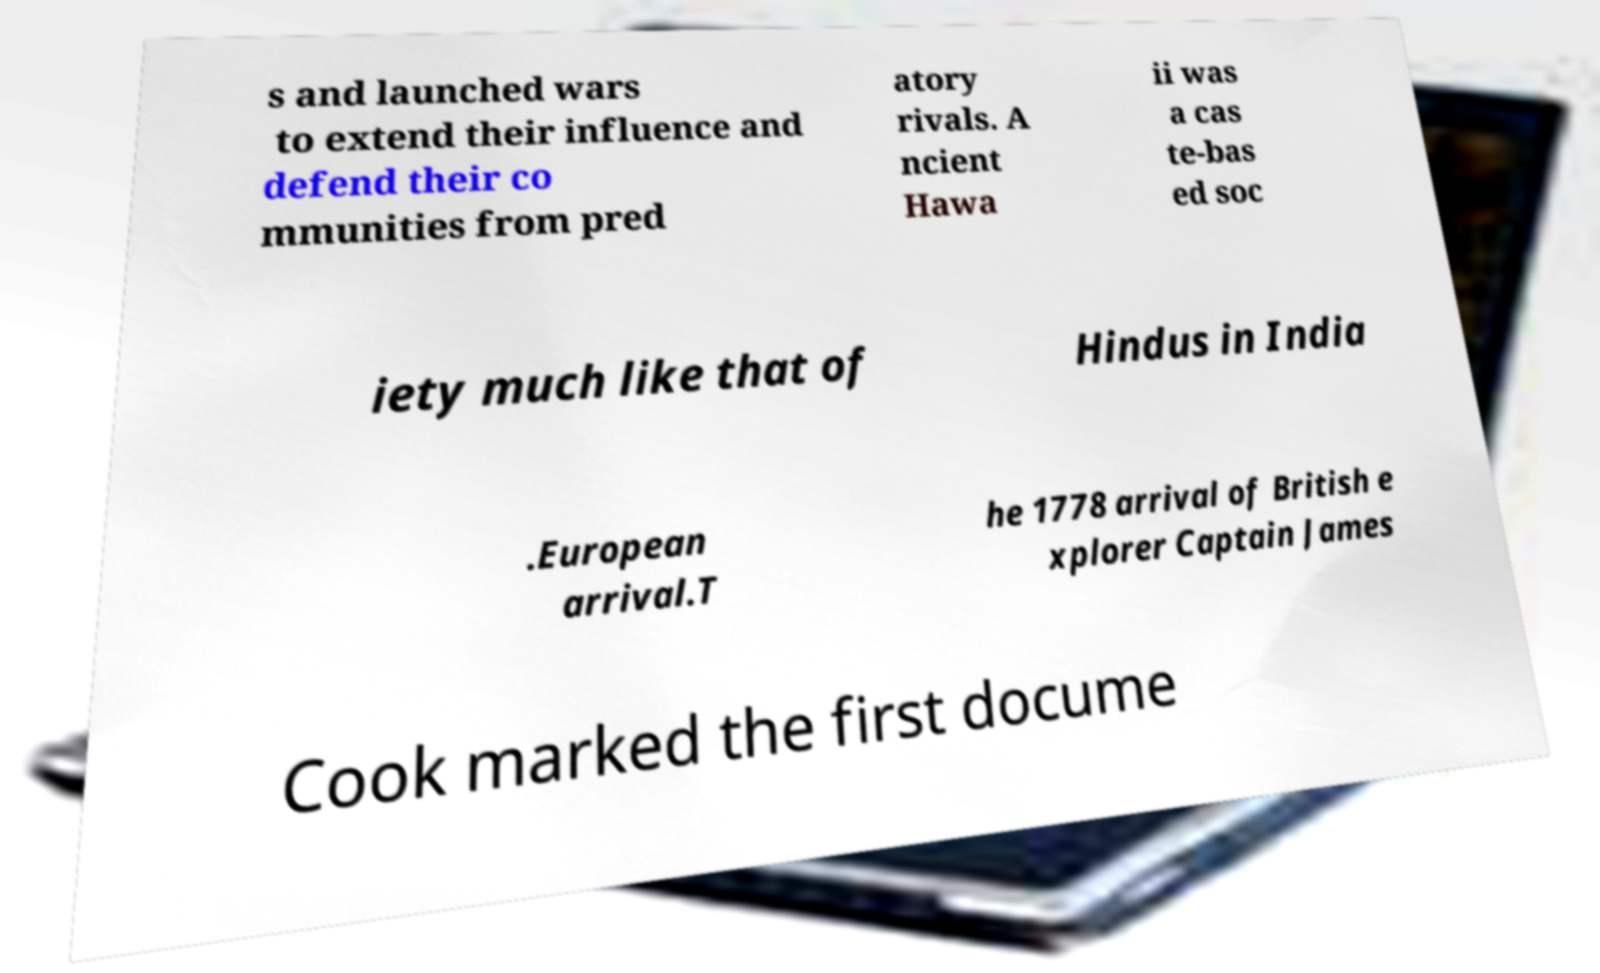I need the written content from this picture converted into text. Can you do that? s and launched wars to extend their influence and defend their co mmunities from pred atory rivals. A ncient Hawa ii was a cas te-bas ed soc iety much like that of Hindus in India .European arrival.T he 1778 arrival of British e xplorer Captain James Cook marked the first docume 